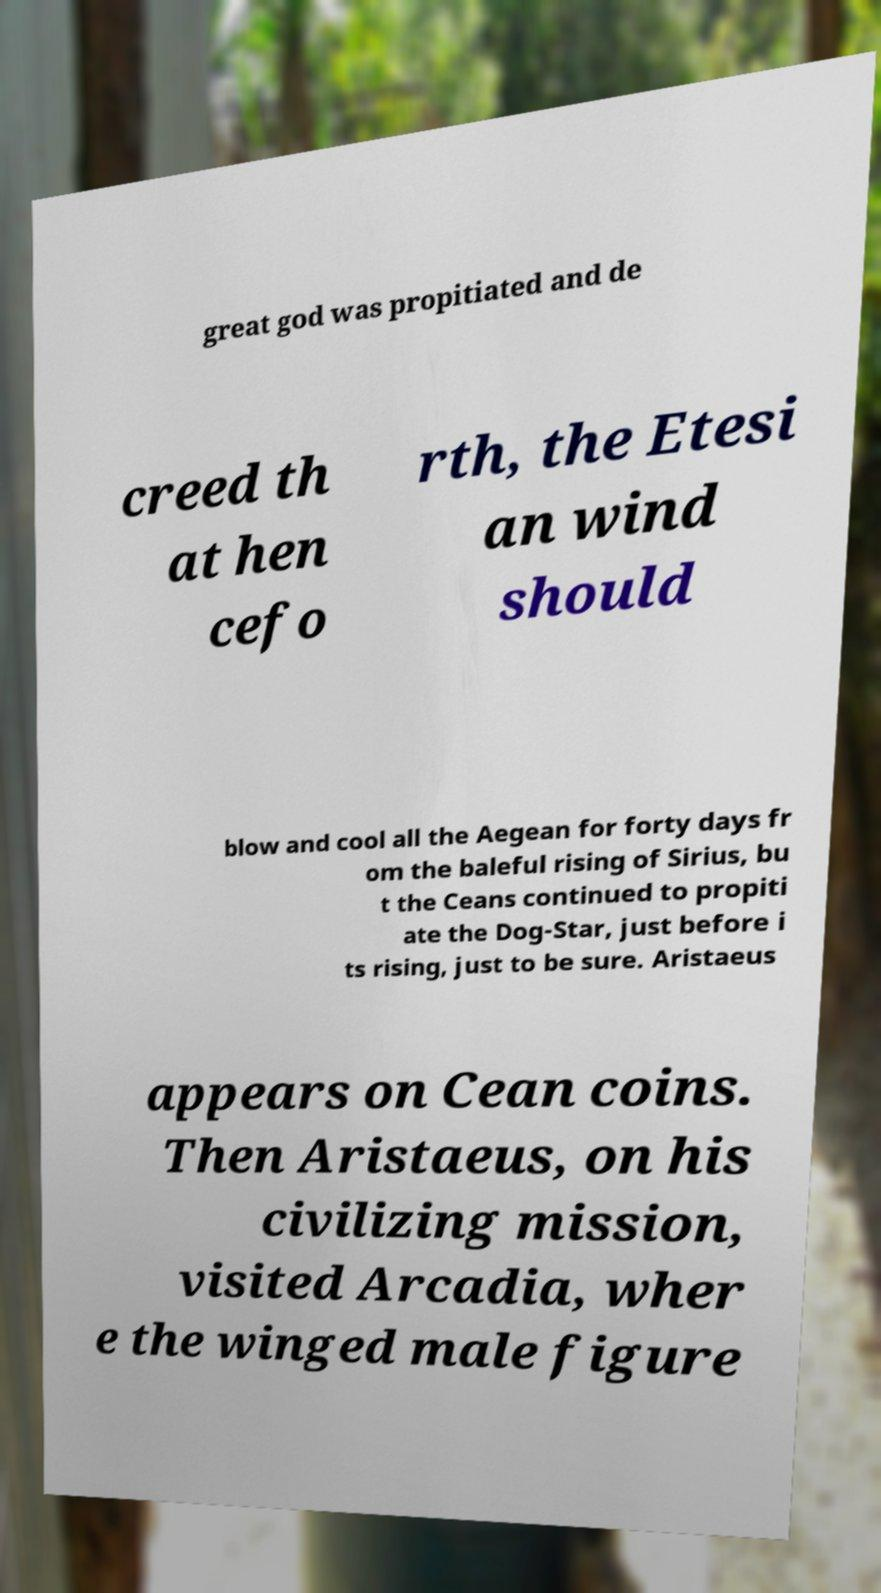Please read and relay the text visible in this image. What does it say? great god was propitiated and de creed th at hen cefo rth, the Etesi an wind should blow and cool all the Aegean for forty days fr om the baleful rising of Sirius, bu t the Ceans continued to propiti ate the Dog-Star, just before i ts rising, just to be sure. Aristaeus appears on Cean coins. Then Aristaeus, on his civilizing mission, visited Arcadia, wher e the winged male figure 